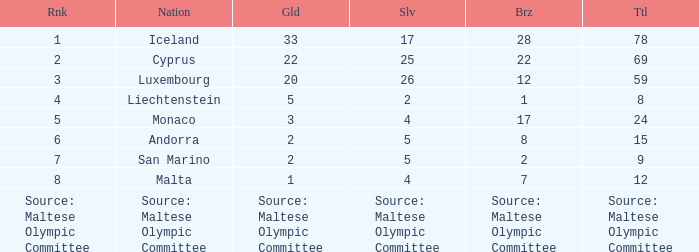For the country possessing 5 gold medals, what is their complete medal tally? 8.0. 